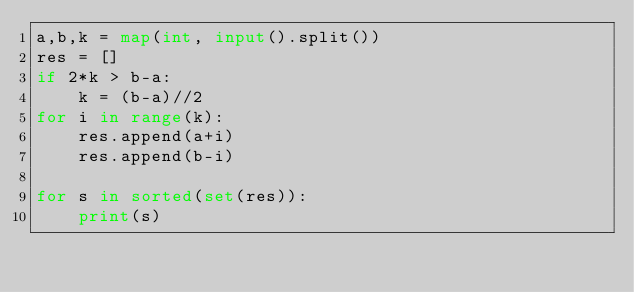Convert code to text. <code><loc_0><loc_0><loc_500><loc_500><_Python_>a,b,k = map(int, input().split())
res = []
if 2*k > b-a:
    k = (b-a)//2
for i in range(k):
    res.append(a+i)
    res.append(b-i)

for s in sorted(set(res)):
    print(s)</code> 